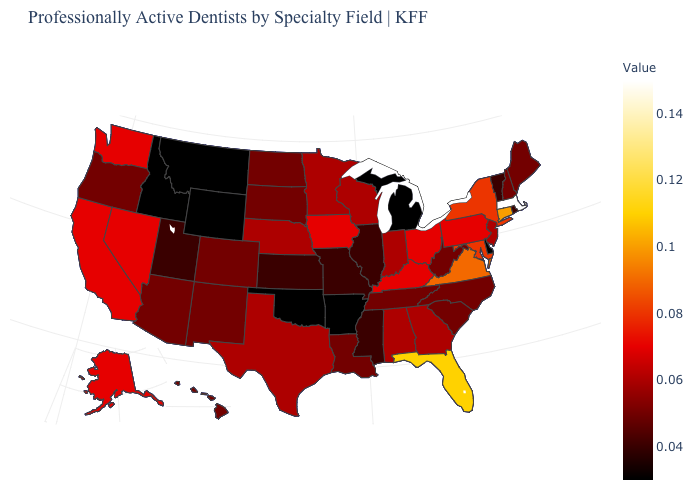Which states hav the highest value in the MidWest?
Concise answer only. Iowa, Ohio. Does South Dakota have the lowest value in the MidWest?
Quick response, please. No. Does South Dakota have a lower value than Oklahoma?
Answer briefly. No. Which states have the highest value in the USA?
Give a very brief answer. Massachusetts. Does Iowa have the lowest value in the USA?
Give a very brief answer. No. 